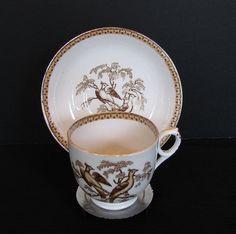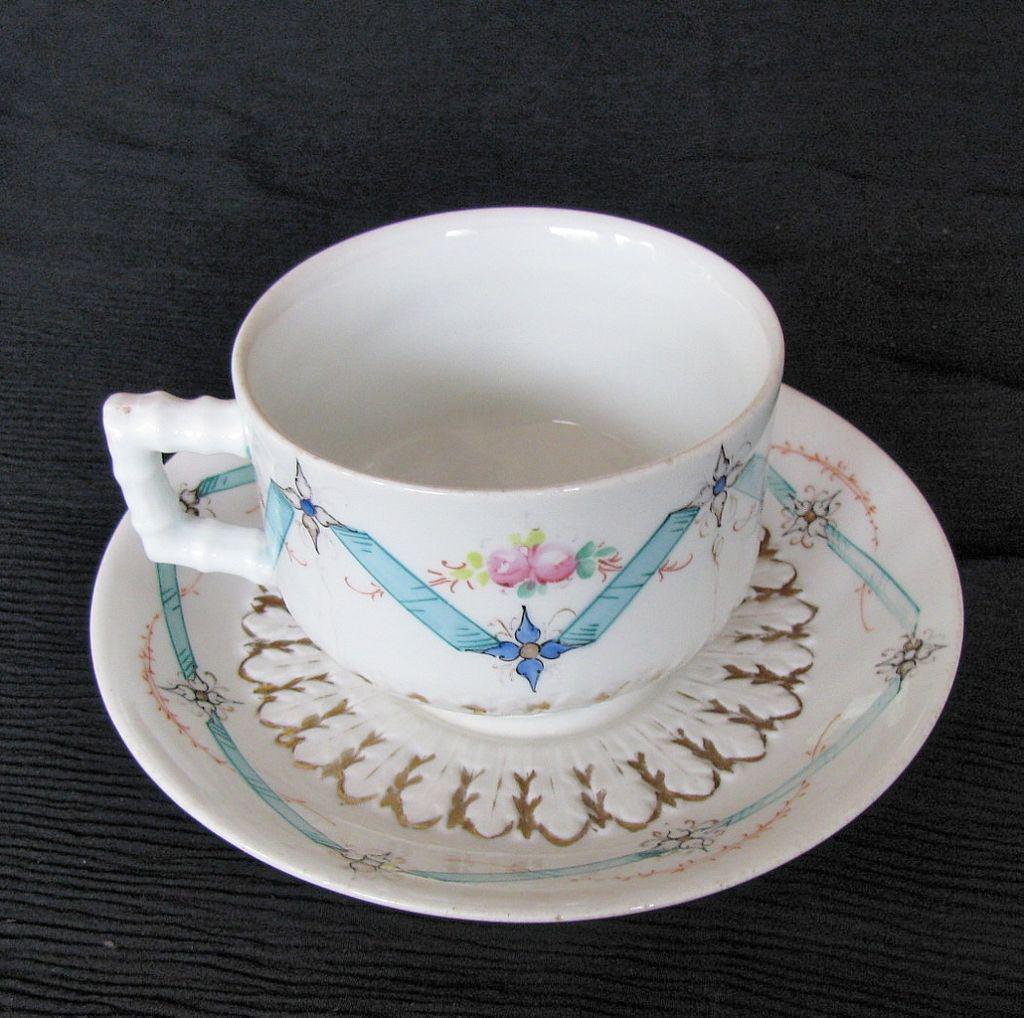The first image is the image on the left, the second image is the image on the right. Analyze the images presented: Is the assertion "One cup is not on a saucer." valid? Answer yes or no. Yes. 